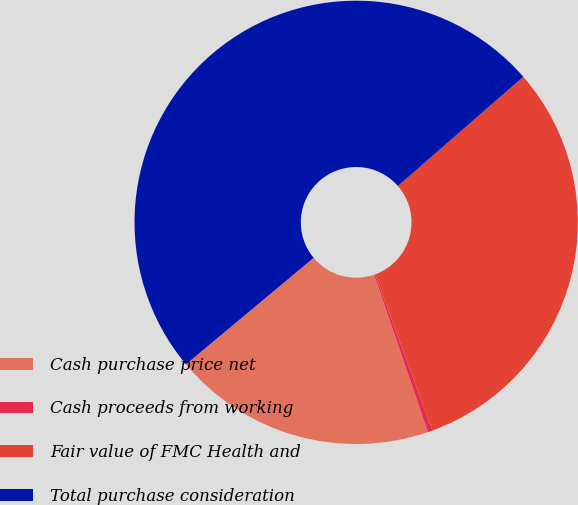Convert chart. <chart><loc_0><loc_0><loc_500><loc_500><pie_chart><fcel>Cash purchase price net<fcel>Cash proceeds from working<fcel>Fair value of FMC Health and<fcel>Total purchase consideration<nl><fcel>19.18%<fcel>0.34%<fcel>30.82%<fcel>49.66%<nl></chart> 